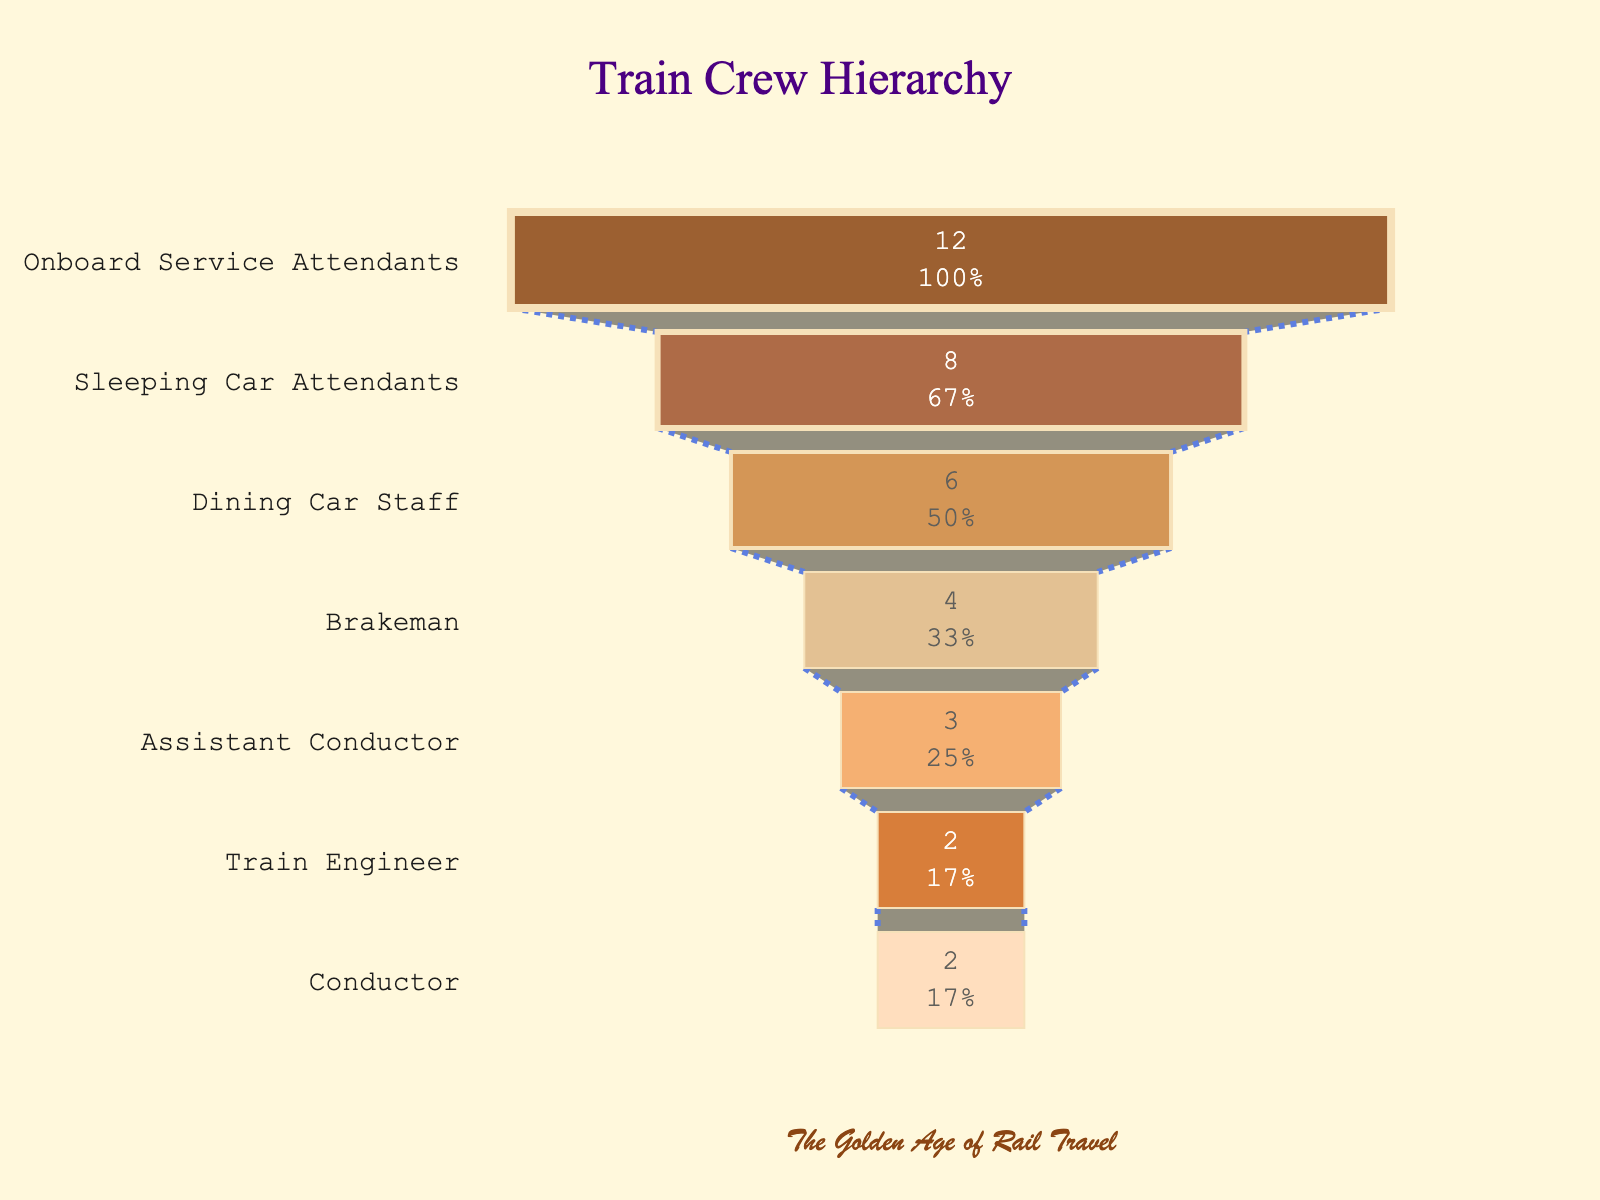What's the title of the figure? The title is typically located at the top center of the figure. In this case, it is "Train Crew Hierarchy".
Answer: Train Crew Hierarchy Which role has the largest number of staff members? The number of staff members is indicated by the length of the bars in the funnel chart. The role with the longest bar, indicating the highest number, is "Onboard Service Attendants" with 12.
Answer: Onboard Service Attendants How many Dining Car Staff members are there? Look at the bar corresponding to the "Dining Car Staff" role on the funnel chart. The number within the bar is 6.
Answer: 6 What is the combined number of Train Engineers and Conductors? Sum the numbers associated with the Train Engineers (2) and Conductors (2). So, 2 + 2 = 4.
Answer: 4 Which role has fewer members: Brakeman or Assistant Conductor? Compare the length of the bars corresponding to "Brakeman" and "Assistant Conductor". Brakeman has 4 and Assistant Conductor has 3, so the Assistant Conductor has fewer members.
Answer: Assistant Conductor What percentage of the total crew does the role of Sleep Car Attendants represent initially? The chart shows the number of Sleeping Car Attendants as 8. The total crew is the sum of all roles: 2 (Train Engineer) + 2 (Conductor) + 3 (Assistant Conductor) + 4 (Brakeman) + 6 (Dining Car Staff) + 8 (Sleeping Car Attendants) + 12 (Onboard Service Attendants) = 37. So, the percentage is (8 / 37) * 100 ≈ 21.62%.
Answer: 21.62% Which roles have an equal number of members? Check for bars with equal lengths. The roles "Train Engineer" and "Conductor" both have 2 members each.
Answer: Train Engineer and Conductor How many more Onboard Service Attendants are there than Dining Car Staff? Subtract the number of Dining Car Staff (6) from the number of Onboard Service Attendants (12). The difference is 12 - 6 = 6.
Answer: 6 What's the difference between the number of Brakemen and Sleeping Car Attendants? Subtract the number of Brakemen (4) from Sleeping Car Attendants (8). The difference is 8 - 4 = 4.
Answer: 4 What is the total number of crew members? Sum the numbers of all roles: 2 (Train Engineer) + 2 (Conductor) + 3 (Assistant Conductor) + 4 (Brakeman) + 6 (Dining Car Staff) + 8 (Sleeping Car Attendants) + 12 (Onboard Service Attendants) = 37.
Answer: 37 